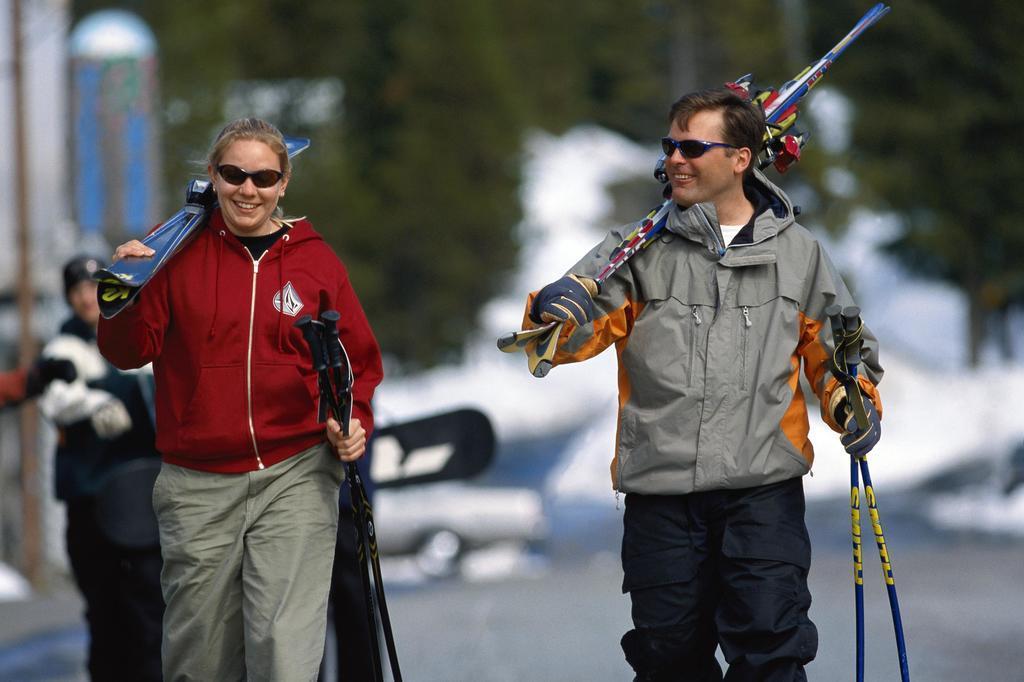Could you give a brief overview of what you see in this image? In this image we can see both the persons are standing and smiling, and holding something in the hand, and at back a person is standing. 